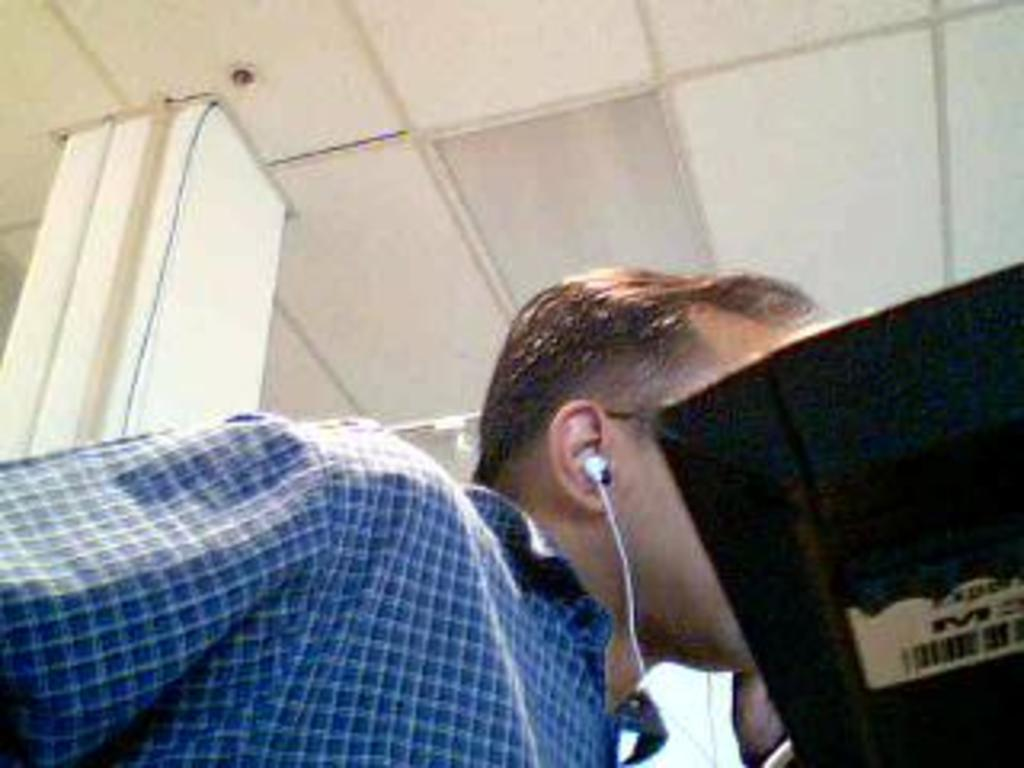Who is present in the image? There is a man in the image. What is the man wearing on his ears? The man is wearing earphones. What type of clothing is the man wearing on his upper body? The man is wearing a shirt. What can be seen on the right side of the image? There is a computer screen on the right side of the image. What part of the room is visible in the image? There is a ceiling visible in the image. What architectural feature can be seen in the image? There is a pillar in the image. What type of scarf is the man wearing in the image? There is no scarf present in the image; the man is wearing a shirt and earphones. What service is the porter providing in the image? There is no porter present in the image; the image features a man wearing earphones and a shirt, a computer screen, a ceiling, and a pillar. 